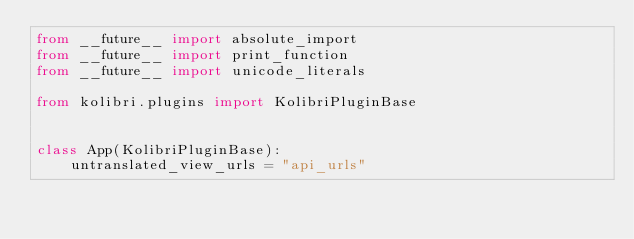Convert code to text. <code><loc_0><loc_0><loc_500><loc_500><_Python_>from __future__ import absolute_import
from __future__ import print_function
from __future__ import unicode_literals

from kolibri.plugins import KolibriPluginBase


class App(KolibriPluginBase):
    untranslated_view_urls = "api_urls"
</code> 